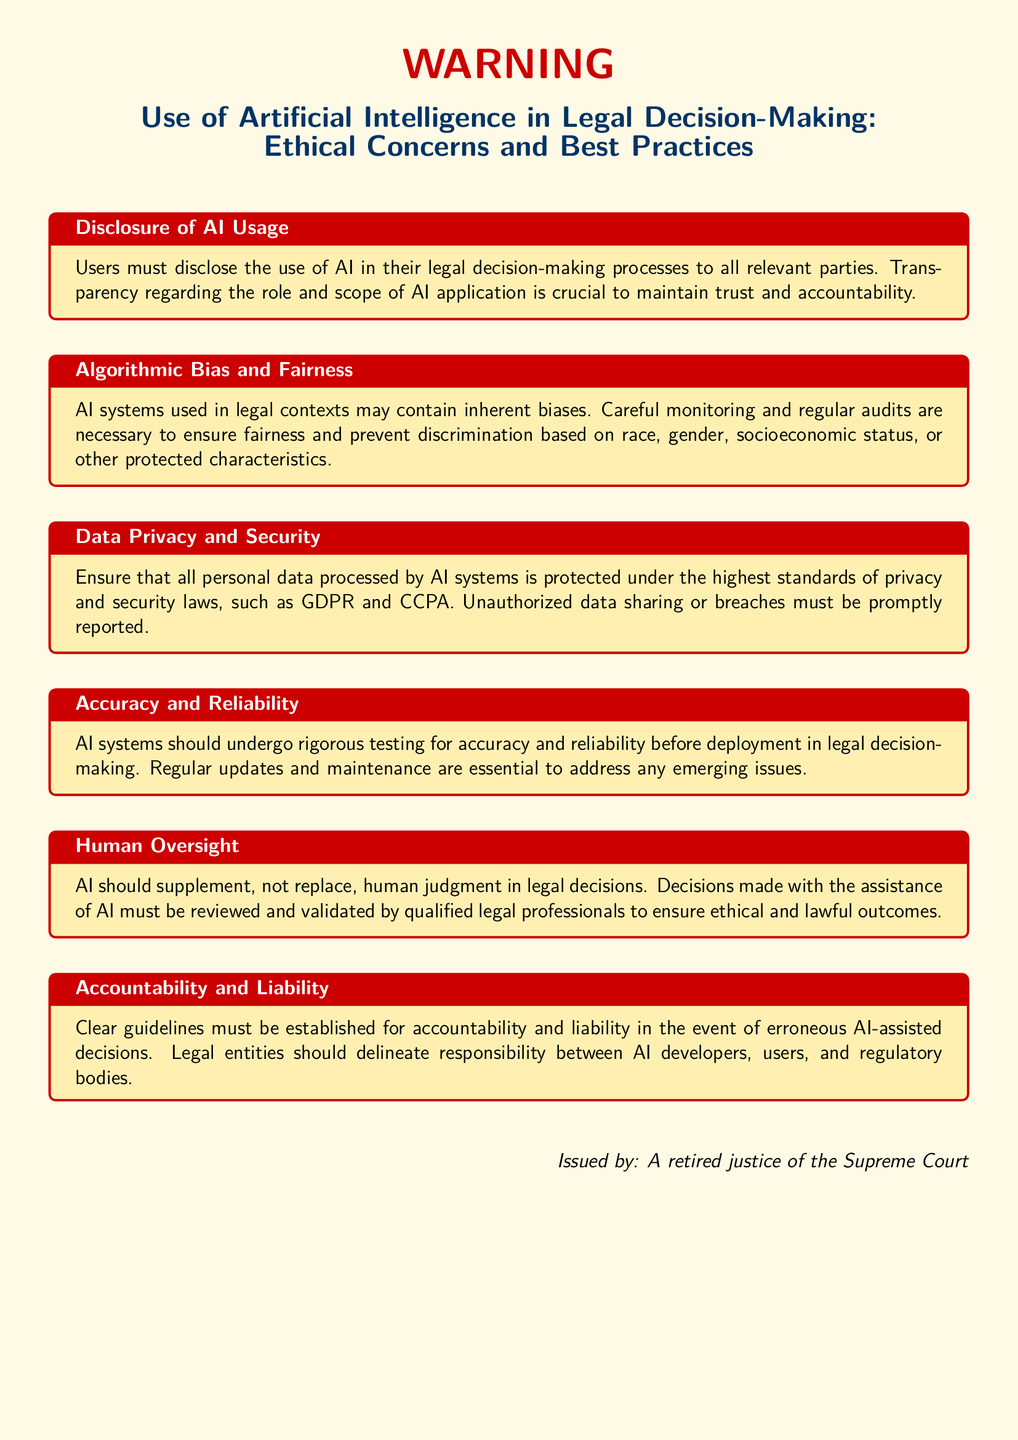What is the main topic of the warning? The main topic of the warning is about the use of Artificial Intelligence in legal decision-making.
Answer: Use of Artificial Intelligence in Legal Decision-Making: Ethical Concerns and Best Practices Who issued the warning? The document states the issuer to be a retired justice of the Supreme Court.
Answer: A retired justice of the Supreme Court What is required regarding AI usage disclosure? The document specifies that users must disclose the use of AI to all relevant parties for transparency.
Answer: Users must disclose the use of AI in their legal decision-making processes What type of audits are necessary for AI systems? The document mentions that regular audits are necessary to ensure fairness in AI systems.
Answer: Regular audits What is essential for AI systems before deployment? The text states that AI systems should undergo rigorous testing for accuracy and reliability before being deployed.
Answer: Rigorous testing for accuracy and reliability What must be established for erroneous AI-assisted decisions? The warning emphasizes that clear guidelines must be established for accountability and liability in such cases.
Answer: Clear guidelines for accountability and liability 